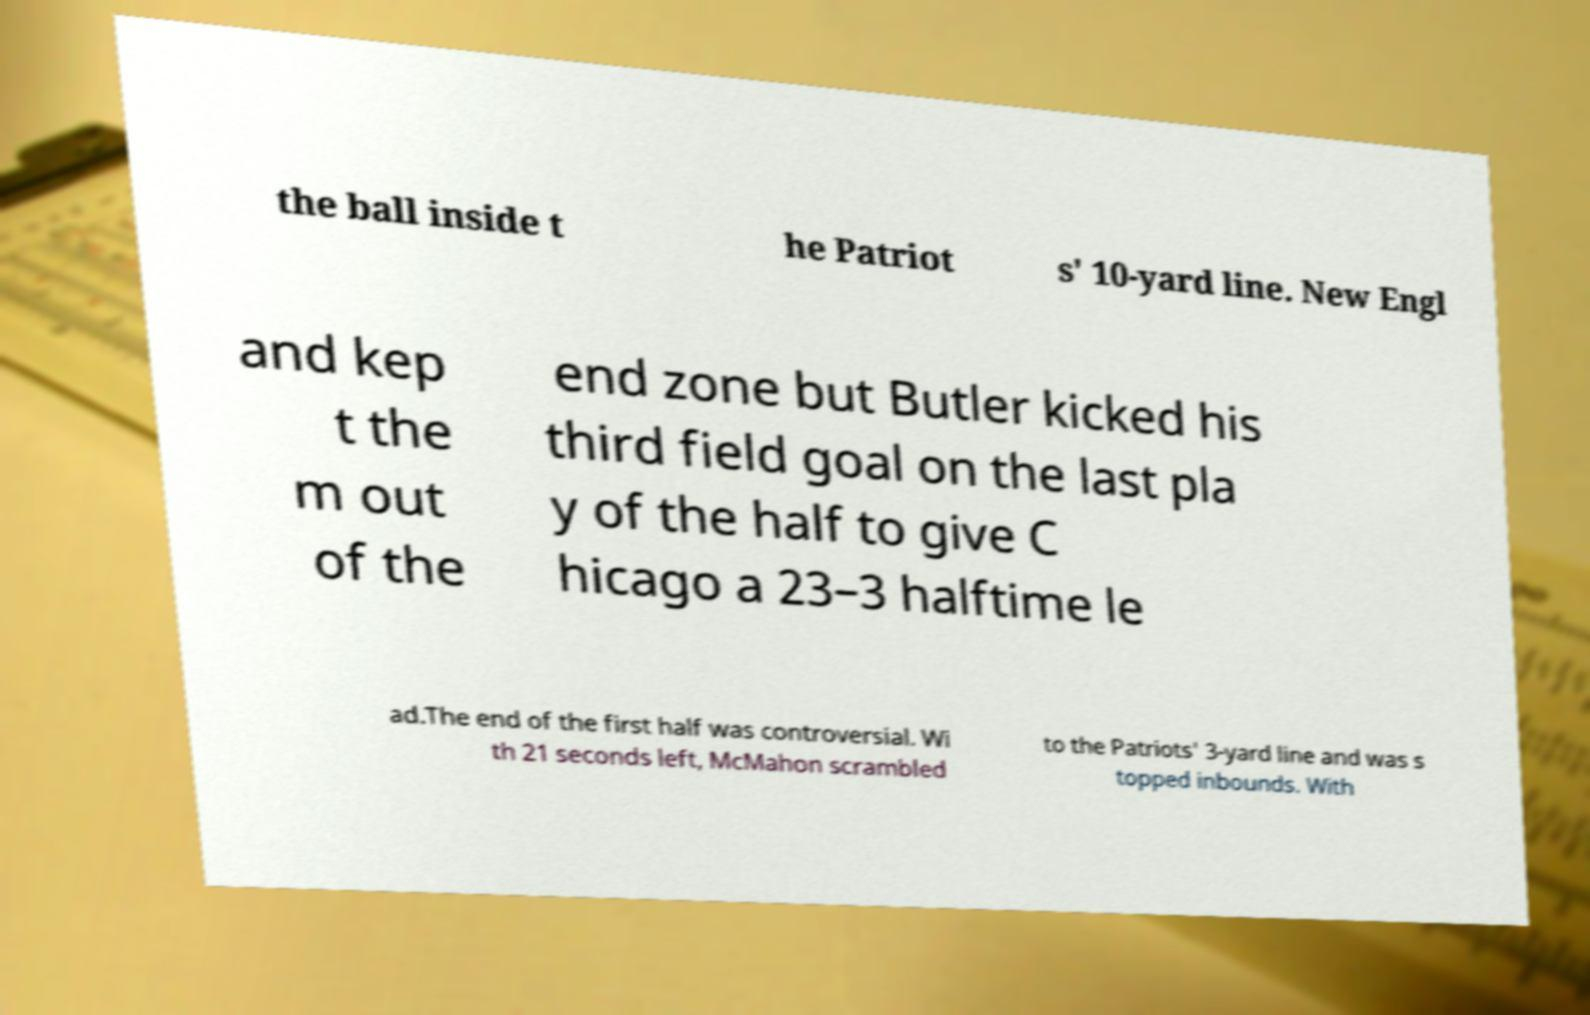What messages or text are displayed in this image? I need them in a readable, typed format. the ball inside t he Patriot s' 10-yard line. New Engl and kep t the m out of the end zone but Butler kicked his third field goal on the last pla y of the half to give C hicago a 23–3 halftime le ad.The end of the first half was controversial. Wi th 21 seconds left, McMahon scrambled to the Patriots' 3-yard line and was s topped inbounds. With 